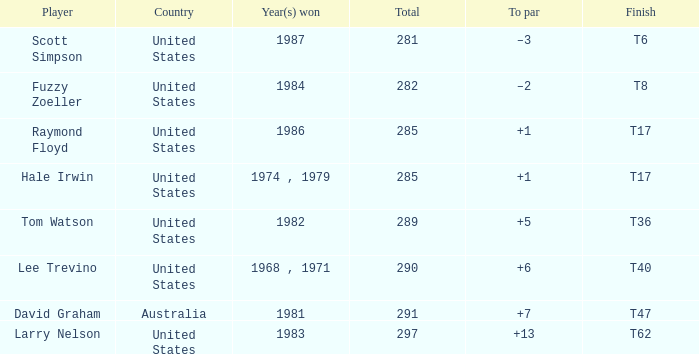In what year was hale irwin victorious with a score of 285 points? 1974 , 1979. 